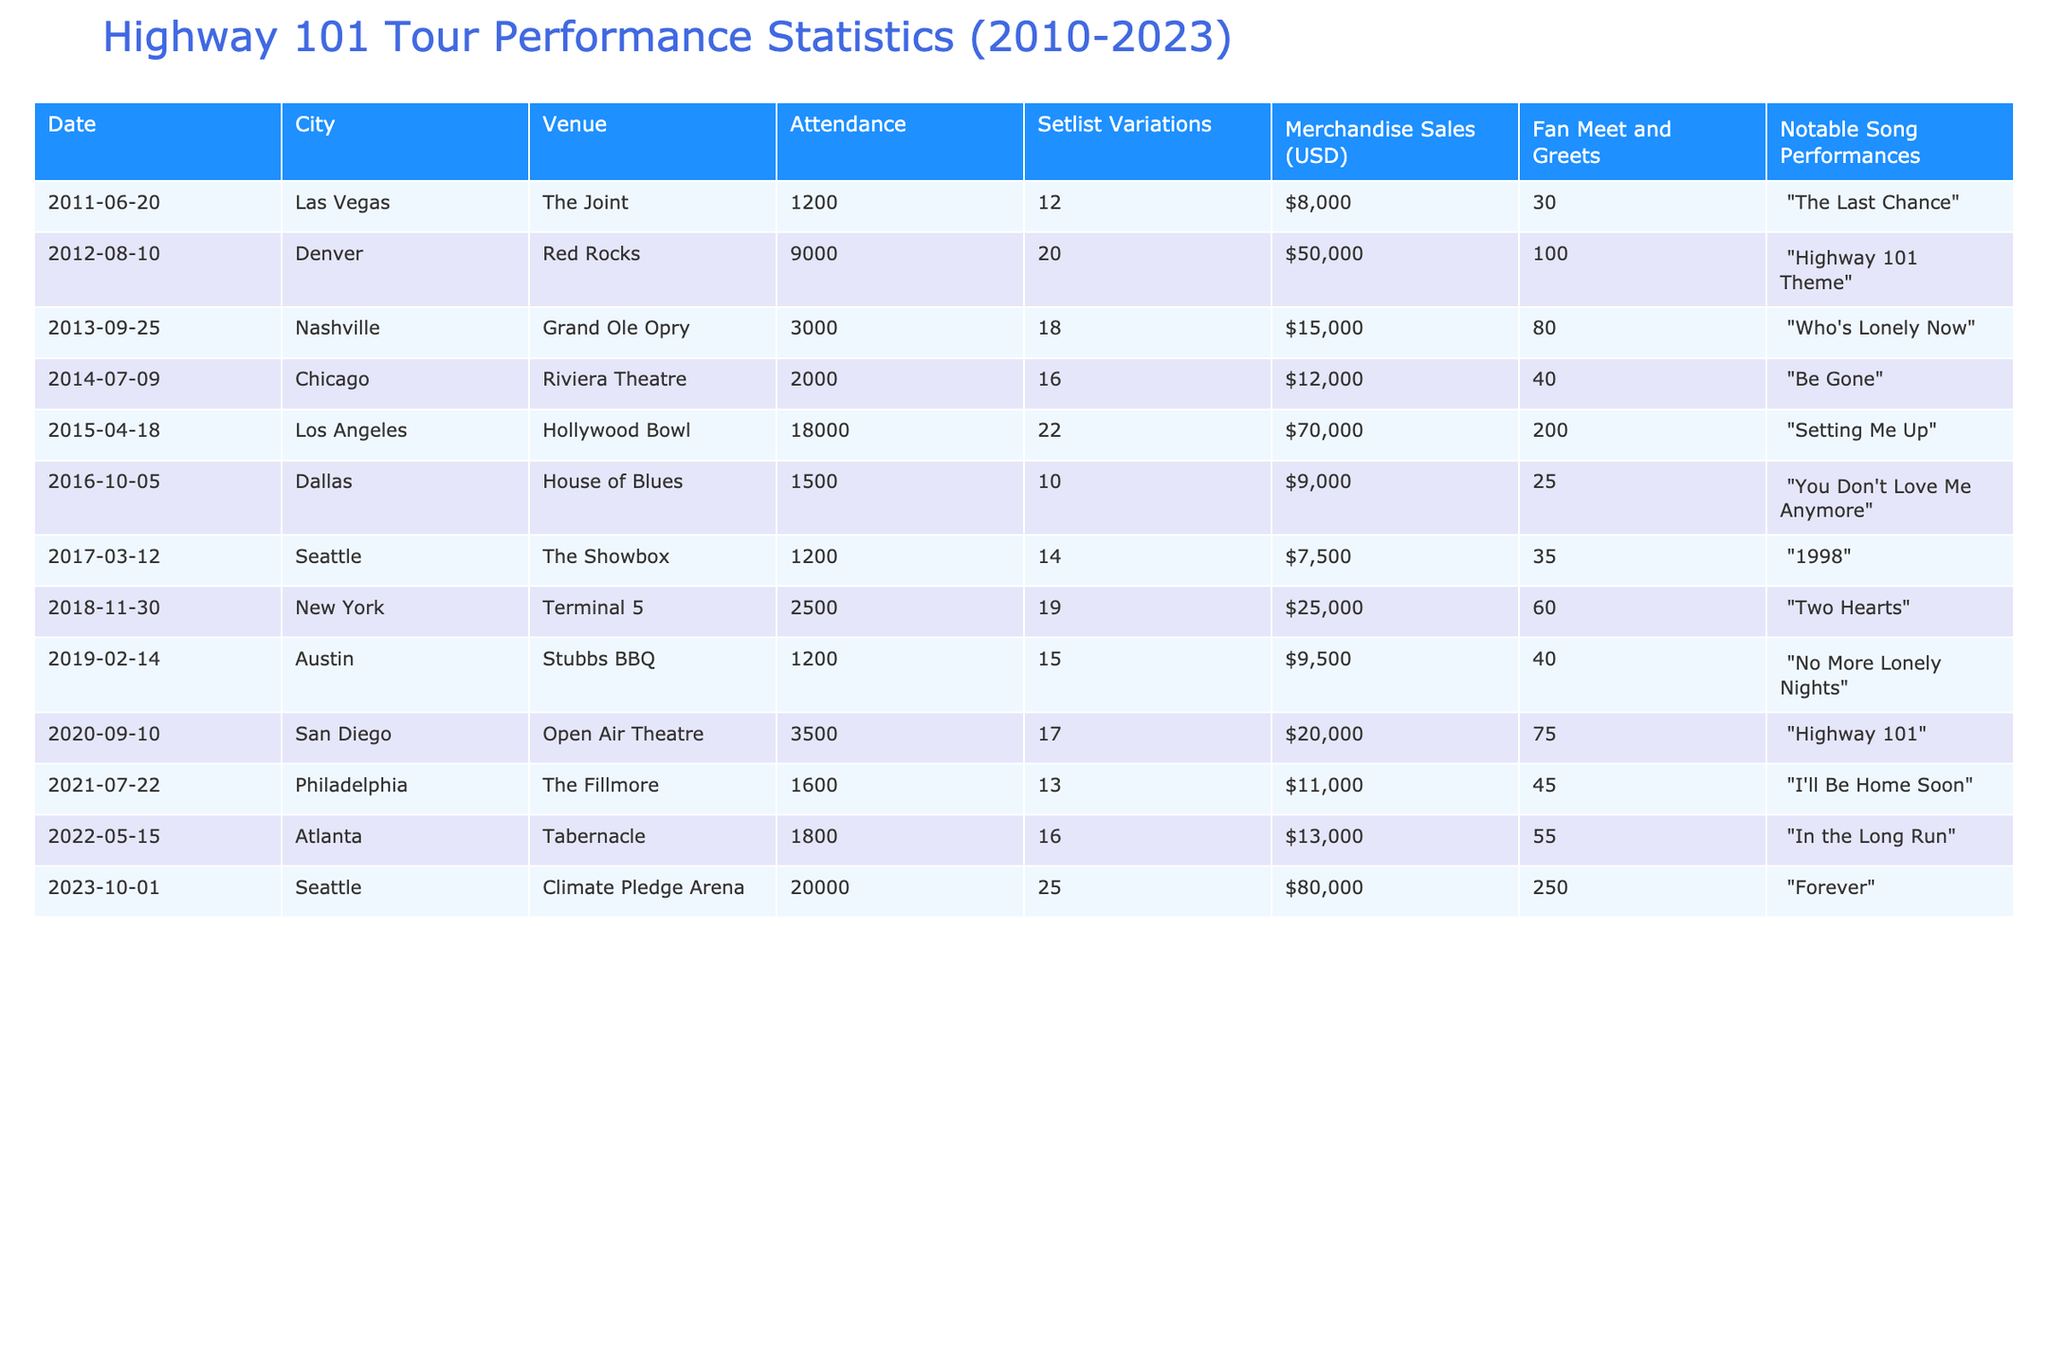What was the highest attendance at a concert from 2010 to 2023? The table lists the attendance figures for each concert, with the highest value being 20,000 for the concert held in Seattle on October 1, 2023.
Answer: 20,000 Which venue had the lowest merchandise sales? By examining the merchandise sales column, the lowest sales of $7,500 occurred at The Showbox in Seattle on March 12, 2017.
Answer: $7,500 How many concerts had a notable song performance featuring "The Last Chance"? Looking through the "Notable Song Performances" column, "The Last Chance" was performed at one concert only, which was in Las Vegas on June 20, 2011.
Answer: 1 What is the average merchandise sales amount for concerts held in 2012 and 2015? The merchandise sales for those years are $50,000 (2012) and $70,000 (2015). The average is calculated as (50,000 + 70,000) / 2 = $120,000 / 2 = $60,000.
Answer: $60,000 In which city did Highway 101 perform the least number of setlist variations? The city with the least setlist variations is Dallas, where only 10 variations were performed on October 5, 2016, as indicated in the Setlist Variations column.
Answer: Dallas Was there a concert with fan meet and greets exceeding 100? Yes, the concert in Denver on August 10, 2012, had 100 fan meet and greets, which is the highest recorded in the table.
Answer: Yes What was the total attendance for Highway 101 concerts held in 2020 and 2022? The total attendance for the concerts in those years is calculated as 3,500 (2020) + 1,800 (2022) = 5,300.
Answer: 5,300 Which concert had the most setlist variations and what was the notable song performed? The concert with the most setlist variations was in Seattle on October 1, 2023, with 25 variations; the notable song performed was "Forever."
Answer: Seattle on October 1, 2023, with "Forever" What percentage of total merchandise sales did the concert in Chicago contribute when compared to all concerts from 2010 to 2023? First, we find the total merchandise sales across all concerts which is: $8,000 + $50,000 + $15,000 + $12,000 + $70,000 + $9,000 + $7,500 + $25,000 + $9,500 + $20,000 + $11,000 + $13,000 + $80,000 = $ 1 0 0 0 0 0. The concert in Chicago made $12,000, so the percentage is (12,000 / 317,000) * 100 = 3.79%
Answer: 3.79% 